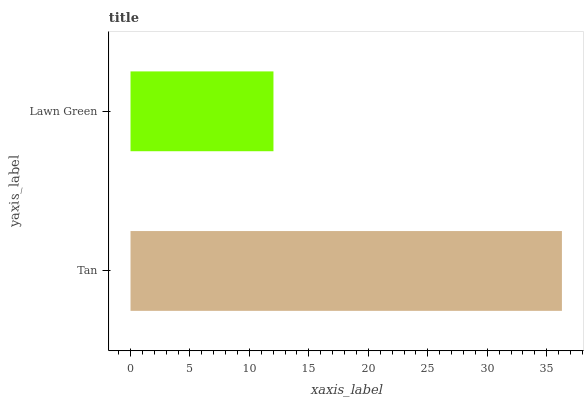Is Lawn Green the minimum?
Answer yes or no. Yes. Is Tan the maximum?
Answer yes or no. Yes. Is Lawn Green the maximum?
Answer yes or no. No. Is Tan greater than Lawn Green?
Answer yes or no. Yes. Is Lawn Green less than Tan?
Answer yes or no. Yes. Is Lawn Green greater than Tan?
Answer yes or no. No. Is Tan less than Lawn Green?
Answer yes or no. No. Is Tan the high median?
Answer yes or no. Yes. Is Lawn Green the low median?
Answer yes or no. Yes. Is Lawn Green the high median?
Answer yes or no. No. Is Tan the low median?
Answer yes or no. No. 